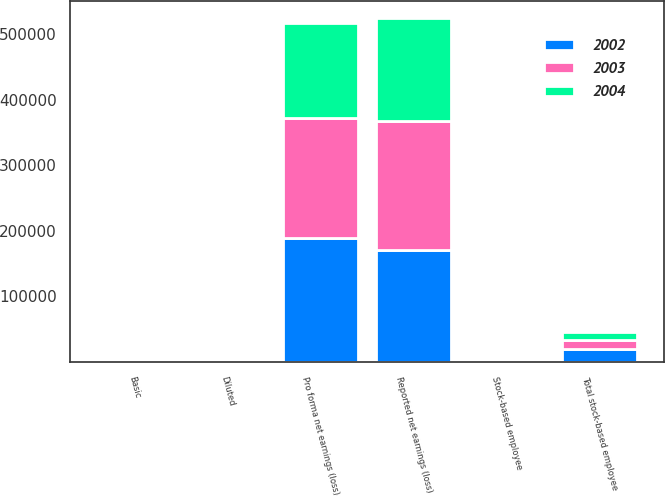Convert chart. <chart><loc_0><loc_0><loc_500><loc_500><stacked_bar_chart><ecel><fcel>Reported net earnings (loss)<fcel>Stock-based employee<fcel>Total stock-based employee<fcel>Pro forma net earnings (loss)<fcel>Basic<fcel>Diluted<nl><fcel>2003<fcel>195977<fcel>103<fcel>13844<fcel>182236<fcel>1.11<fcel>0.96<nl><fcel>2004<fcel>157664<fcel>126<fcel>12948<fcel>144842<fcel>0.91<fcel>0.85<nl><fcel>2002<fcel>170674<fcel>1221<fcel>19641<fcel>189094<fcel>0.99<fcel>0.9<nl></chart> 